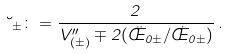<formula> <loc_0><loc_0><loc_500><loc_500>\lambda _ { \pm } \colon = \frac { 2 } { V ^ { \prime \prime } _ { ( \pm ) } \mp 2 ( \ddot { \phi } _ { 0 \pm } / \dot { \phi } _ { 0 \pm } ) } \, .</formula> 